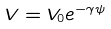<formula> <loc_0><loc_0><loc_500><loc_500>V = V _ { 0 } e ^ { - \gamma \psi }</formula> 